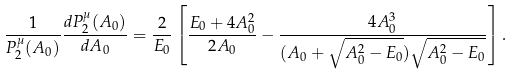Convert formula to latex. <formula><loc_0><loc_0><loc_500><loc_500>\frac { 1 } { P _ { 2 } ^ { \mu } ( A _ { 0 } ) } \frac { d P _ { 2 } ^ { \mu } ( A _ { 0 } ) } { d A _ { 0 } } = \frac { 2 } { E _ { 0 } } \left [ \frac { E _ { 0 } + 4 A _ { 0 } ^ { 2 } } { 2 A _ { 0 } } - \frac { 4 A _ { 0 } ^ { 3 } } { ( A _ { 0 } + \sqrt { A _ { 0 } ^ { 2 } - E _ { 0 } } ) \sqrt { A _ { 0 } ^ { 2 } - E _ { 0 } } } \right ] .</formula> 